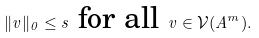<formula> <loc_0><loc_0><loc_500><loc_500>\| v \| _ { 0 } \leq s \text { for all } v \in \mathcal { V } ( A ^ { m } ) .</formula> 